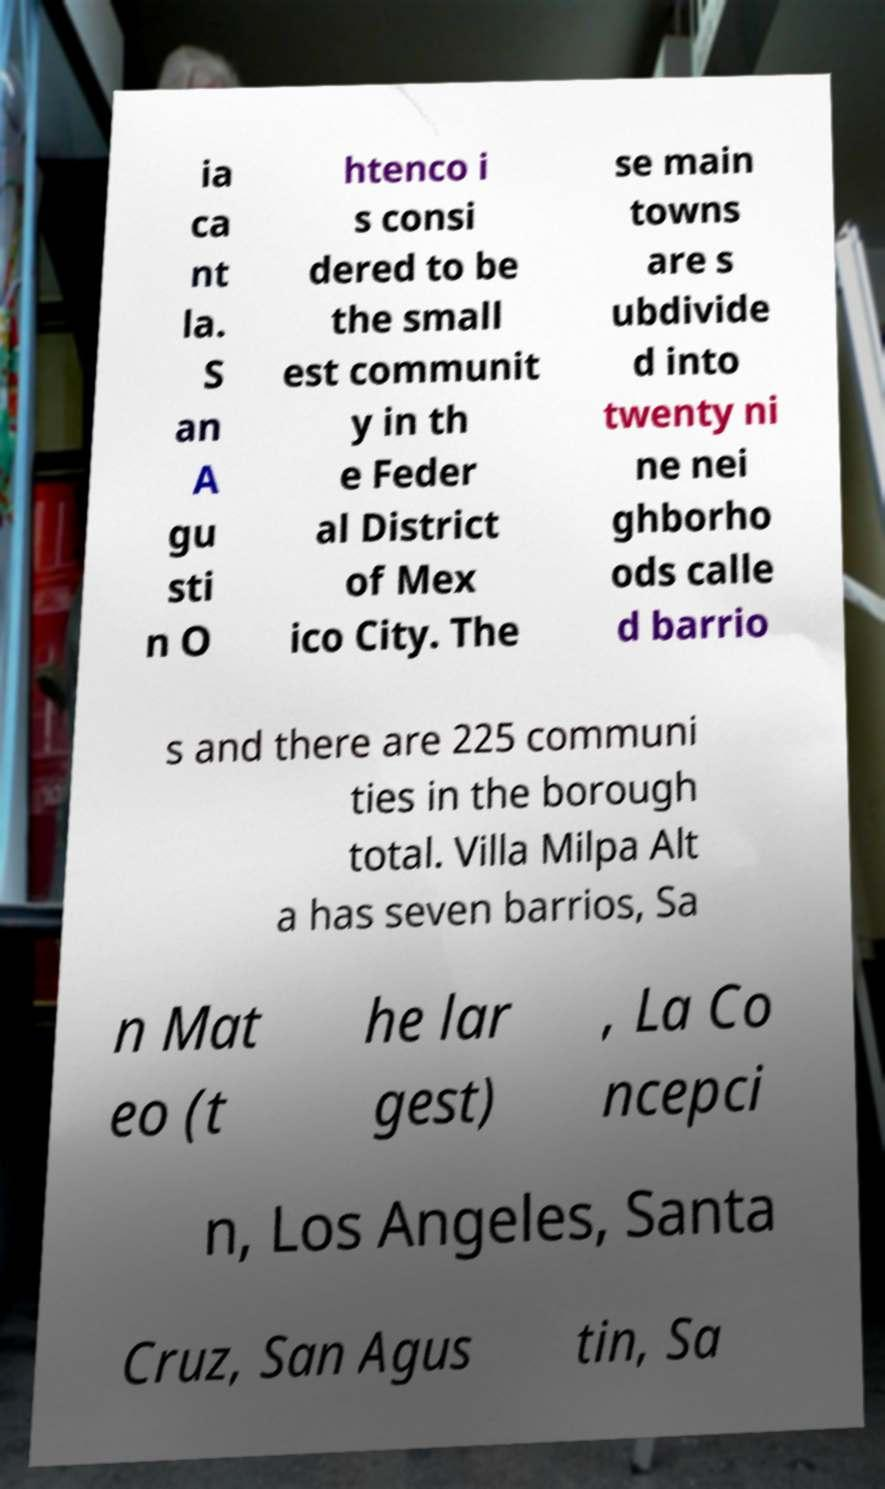Please read and relay the text visible in this image. What does it say? ia ca nt la. S an A gu sti n O htenco i s consi dered to be the small est communit y in th e Feder al District of Mex ico City. The se main towns are s ubdivide d into twenty ni ne nei ghborho ods calle d barrio s and there are 225 communi ties in the borough total. Villa Milpa Alt a has seven barrios, Sa n Mat eo (t he lar gest) , La Co ncepci n, Los Angeles, Santa Cruz, San Agus tin, Sa 